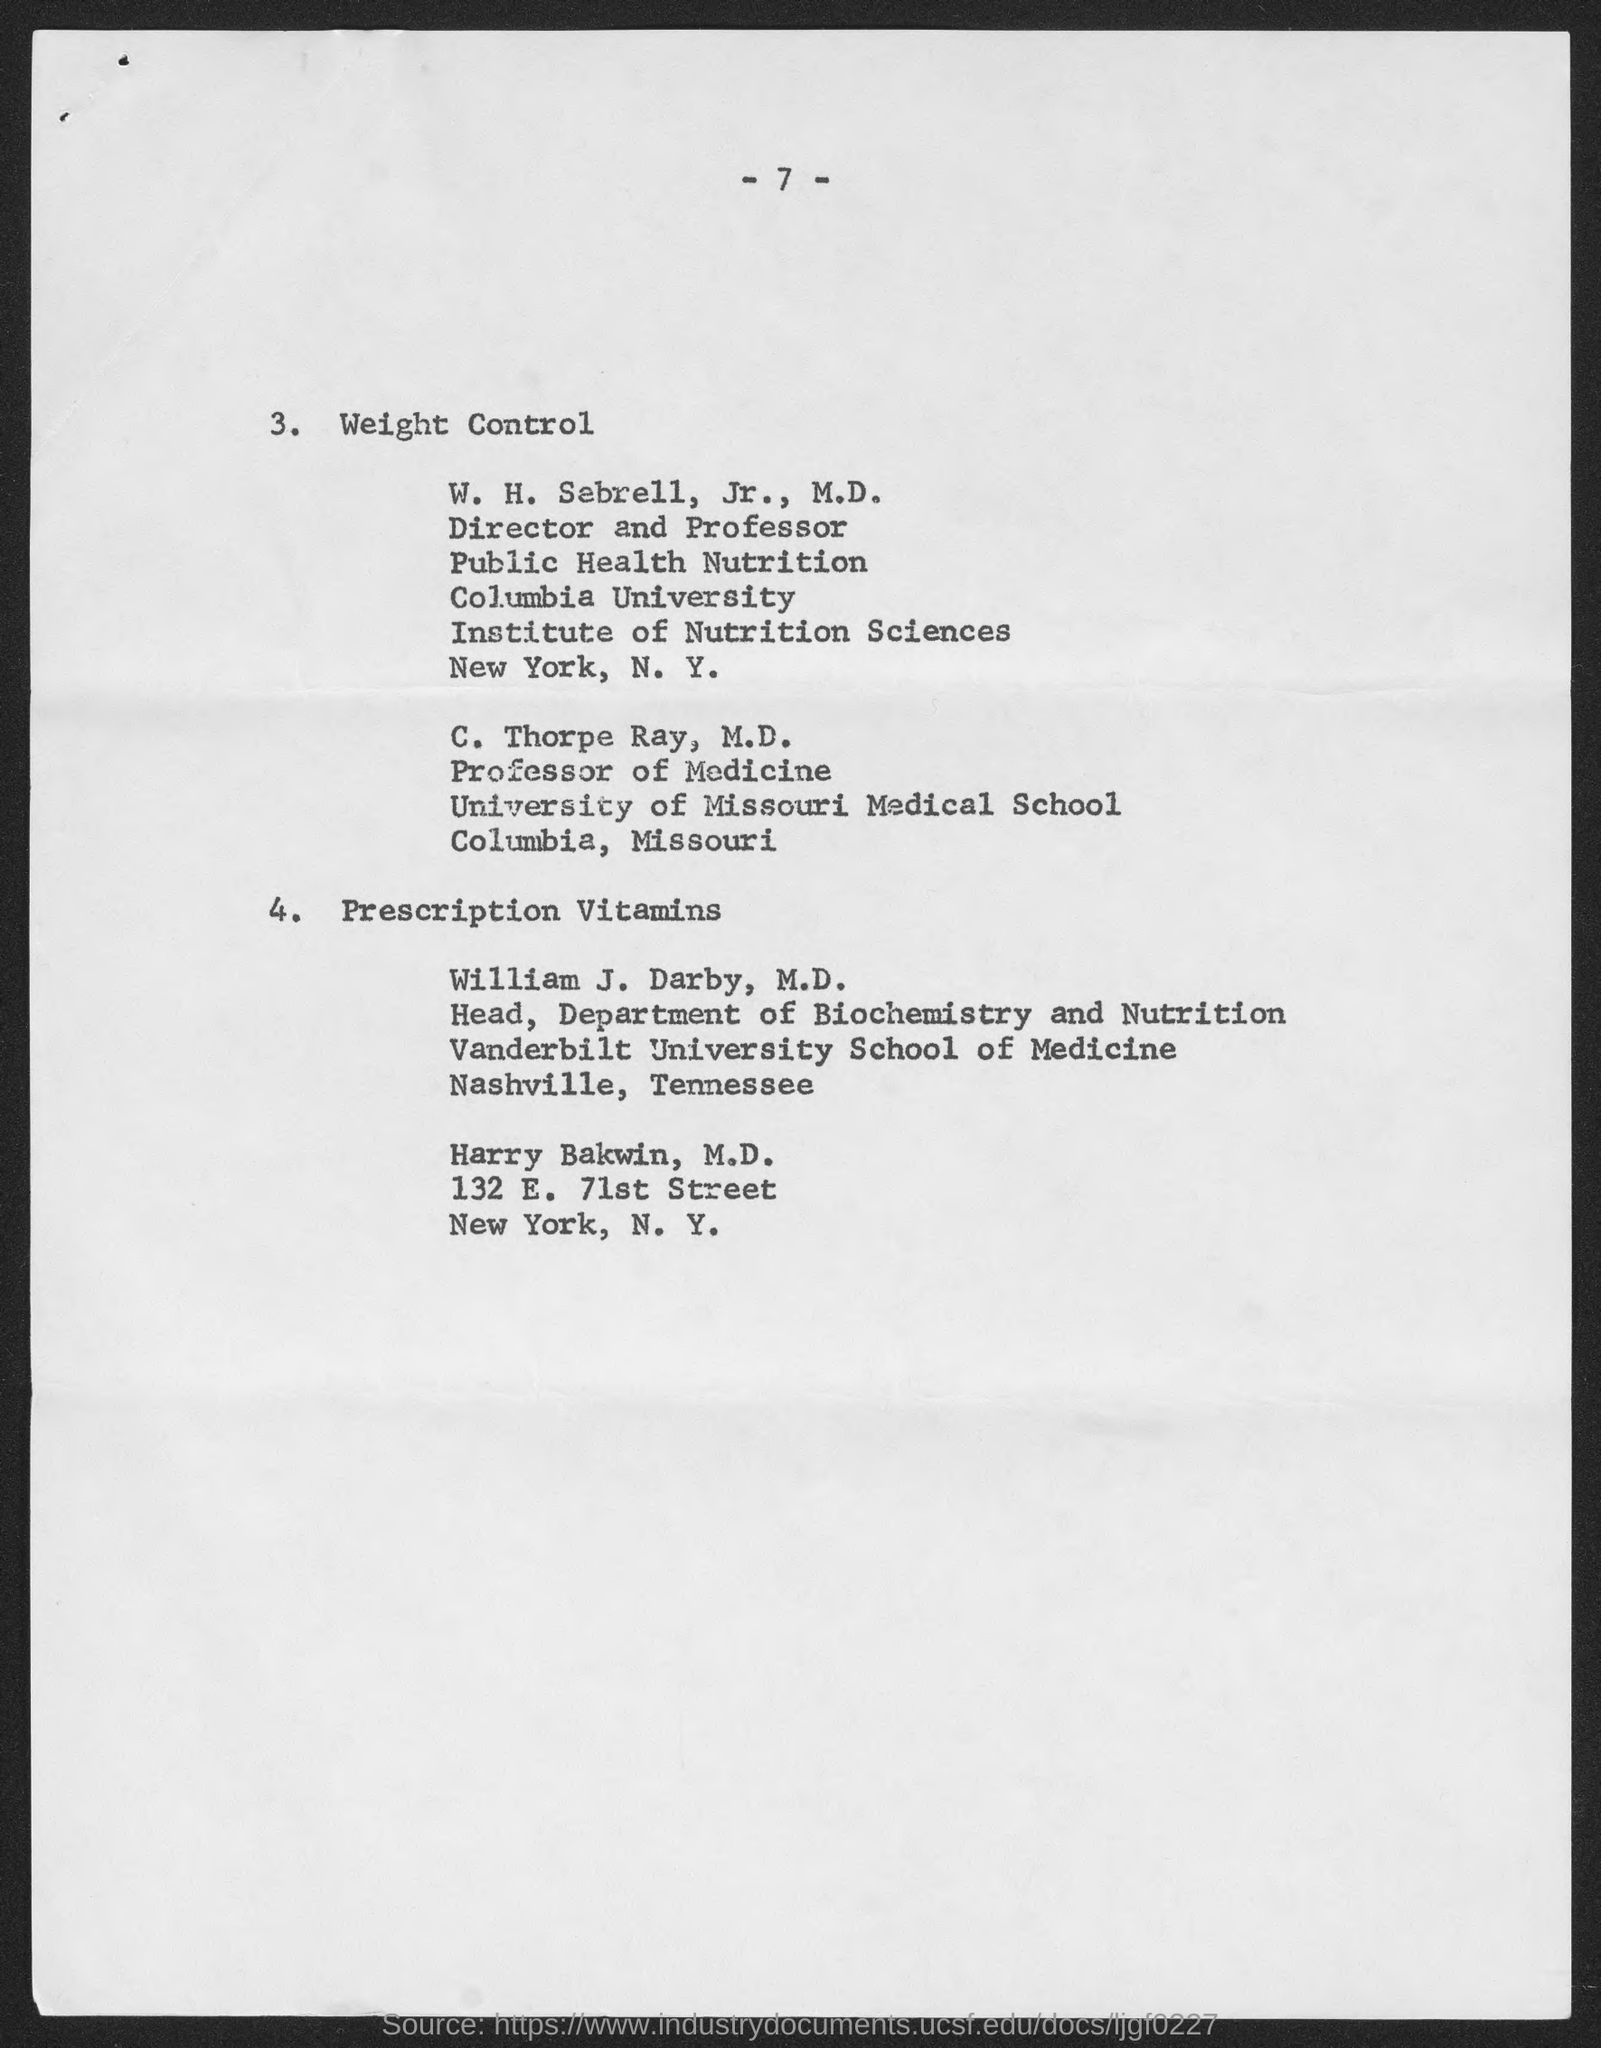Identify some key points in this picture. Dr. C. Thorpe Ray is a Professor of Medicine. William J. Darby, M.D. holds the designation of Head of the Department of Biochemistry and Nutrition. The page number mentioned in this document is 7. 